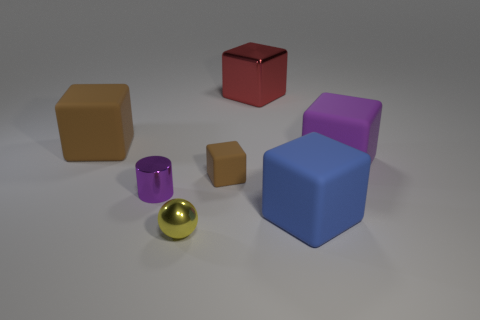Is the number of big blocks that are to the left of the purple cylinder the same as the number of small rubber objects?
Keep it short and to the point. Yes. Do the large block that is in front of the purple rubber cube and the big block that is left of the red thing have the same material?
Keep it short and to the point. Yes. There is a big rubber thing left of the small yellow sphere; is its shape the same as the brown matte thing that is in front of the big brown matte object?
Offer a very short reply. Yes. Is the number of small yellow metal balls that are on the right side of the small purple cylinder less than the number of small purple shiny cylinders?
Give a very brief answer. No. How many rubber blocks are the same color as the tiny shiny cylinder?
Ensure brevity in your answer.  1. What is the size of the thing right of the blue rubber object?
Ensure brevity in your answer.  Large. What is the shape of the brown thing in front of the matte block to the left of the small thing in front of the large blue matte block?
Offer a terse response. Cube. What is the shape of the shiny object that is both in front of the purple matte block and behind the big blue cube?
Provide a short and direct response. Cylinder. Is there another red metal cube of the same size as the red block?
Keep it short and to the point. No. There is a large matte object in front of the purple cube; is it the same shape as the tiny purple shiny thing?
Your answer should be compact. No. 